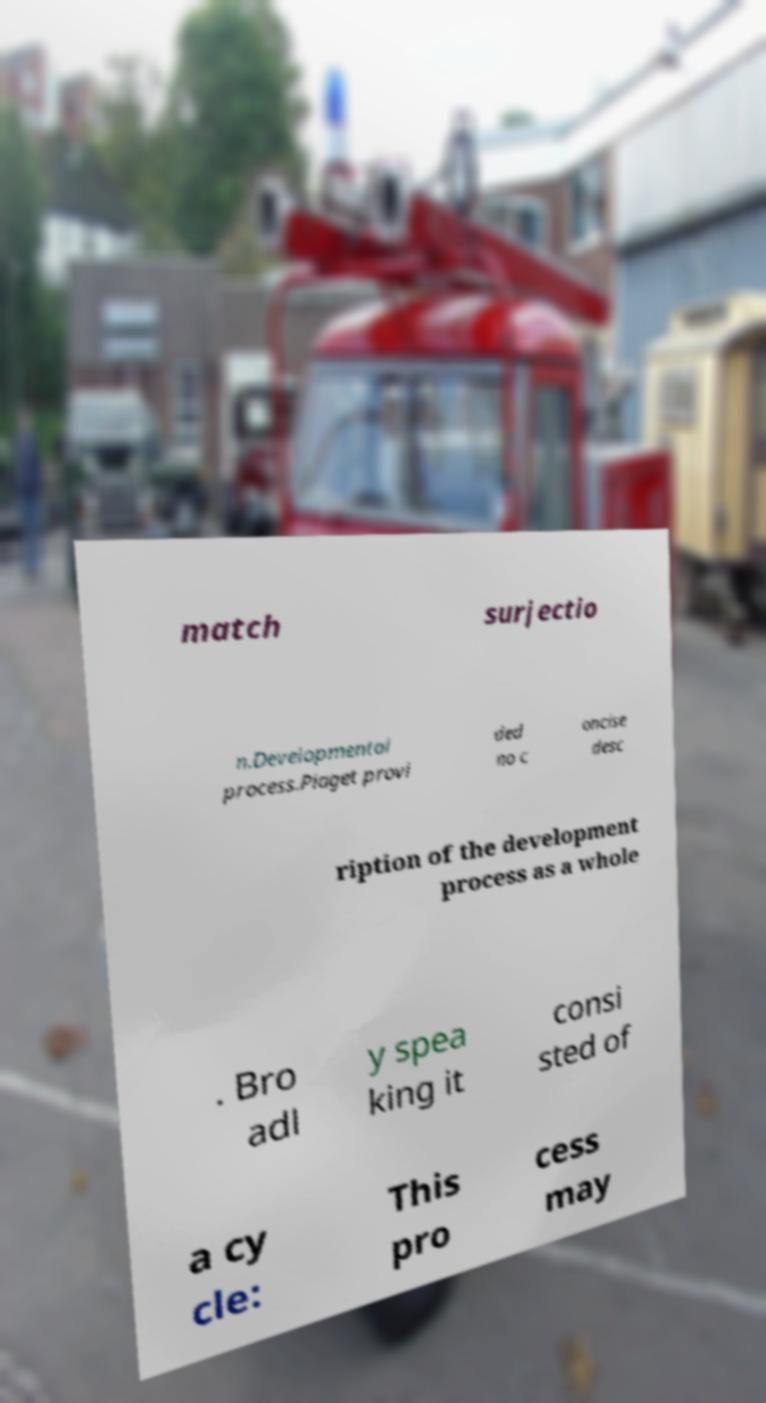Could you assist in decoding the text presented in this image and type it out clearly? match surjectio n.Developmental process.Piaget provi ded no c oncise desc ription of the development process as a whole . Bro adl y spea king it consi sted of a cy cle: This pro cess may 